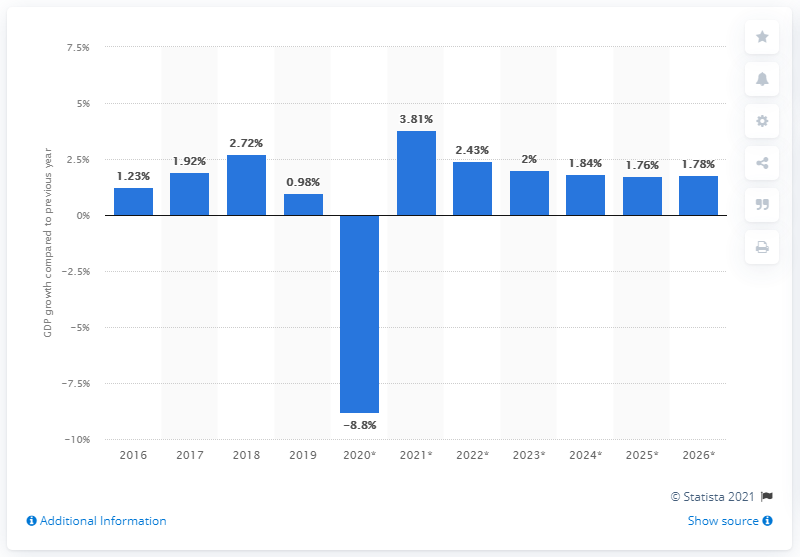Highlight a few significant elements in this photo. In 2019, Tunisia's gross domestic product (GDP) grew by 0.98%. 